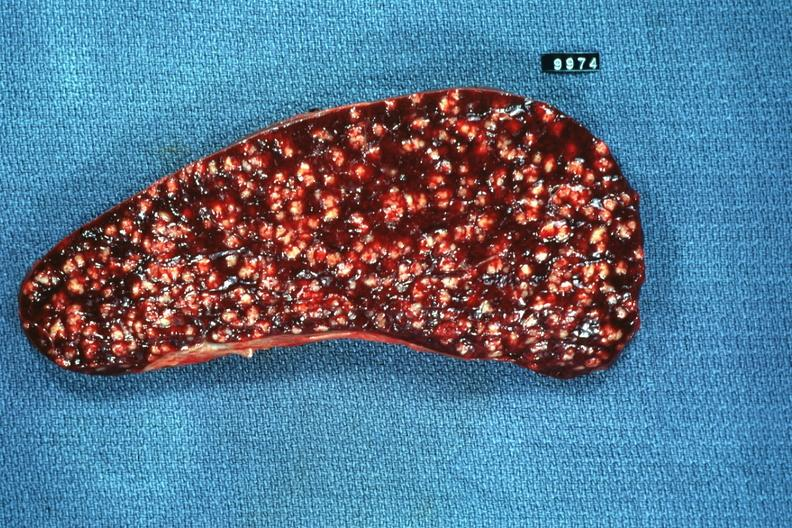s hematologic present?
Answer the question using a single word or phrase. Yes 